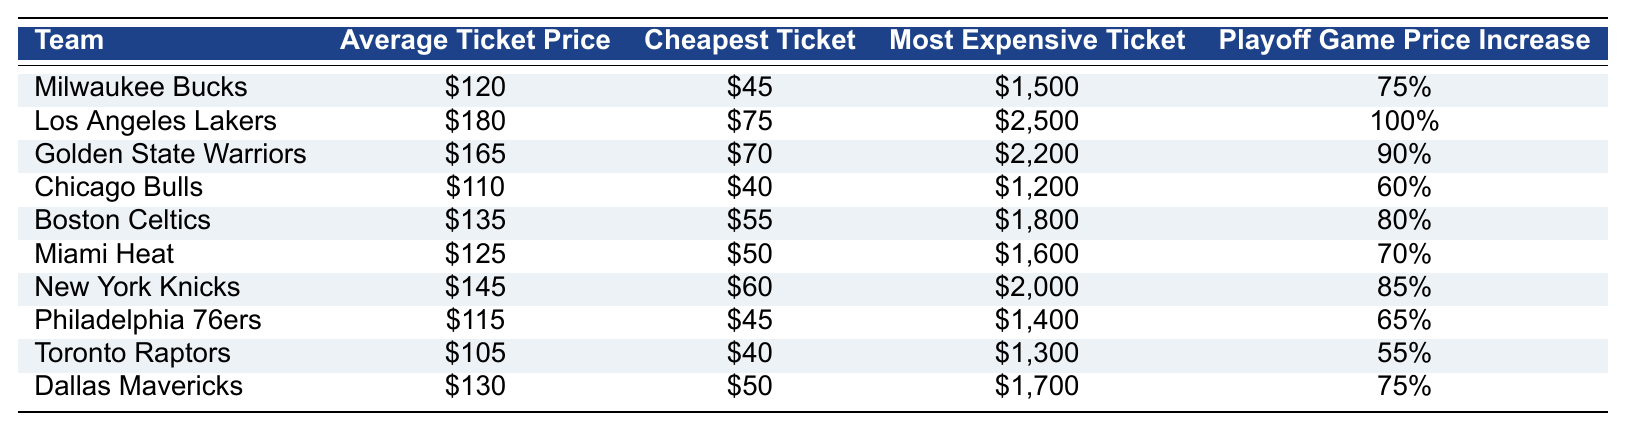What's the average ticket price for the Milwaukee Bucks? The average ticket price listed for the Milwaukee Bucks in the table is $120.
Answer: $120 Which team has the cheapest ticket price? The cheapest ticket price in the table is $40, which belongs to both the Chicago Bulls and Toronto Raptors.
Answer: Chicago Bulls and Toronto Raptors What is the most expensive ticket price for the Golden State Warriors? The most expensive ticket price for the Golden State Warriors listed in the table is $2,200.
Answer: $2,200 How much does the average ticket price for the Milwaukee Bucks exceed that of the Toronto Raptors? The average ticket price for the Bucks is $120 and for the Raptors is $105. The difference is calculated as $120 - $105 = $15.
Answer: $15 Is the Milwaukee Bucks average ticket price cheaper than the average ticket price for the Los Angeles Lakers? The average ticket price for the Bucks is $120, while for the Lakers it is $180. Since $120 is less than $180, the answer is yes.
Answer: Yes Which team has the highest playoff game price increase and what is that percentage? The highest playoff game price increase is 100%, which applies to the Los Angeles Lakers.
Answer: Los Angeles Lakers, 100% If you compare the average ticket prices of the Milwaukee Bucks and the Boston Celtics, which team is cheaper on average? The average ticket price for the Bucks is $120, while for the Celtics it is $135. Since $120 is less than $135, the Bucks are cheaper.
Answer: Milwaukee Bucks How much more do the Miami Heat charge on average for their tickets compared to the Chicago Bulls? The average ticket price for the Heat is $125 and for the Bulls it is $110. The difference is $125 - $110 = $15.
Answer: $15 What is the average ticket price of the teams listed in the table? To calculate the average, sum up the average ticket prices of all teams: ($120 + $180 + $165 + $110 + $135 + $125 + $145 + $115 + $105 + $130) = $1,405 and divide by 10, giving an average of $140.50.
Answer: $140.50 Does the Philadelphia 76ers have a higher playoff game price increase percentage than the Toronto Raptors? The Philadelphia 76ers have a playoff game price increase of 65% while the Raptors have 55%. Since 65% is greater than 55%, the answer is yes.
Answer: Yes 